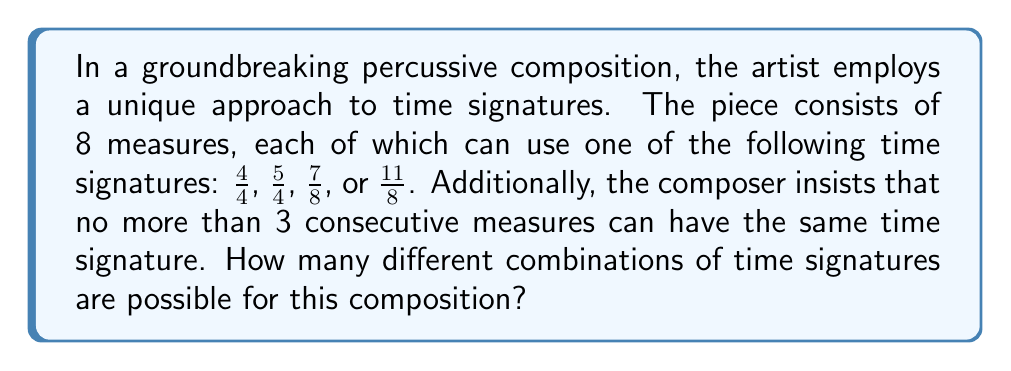Solve this math problem. Let's approach this step-by-step:

1) First, we need to consider the total number of possible combinations without the restriction:
   With 4 choices for each of the 8 measures, we would have $4^8 = 65,536$ combinations.

2) However, we need to subtract the combinations that violate the rule of no more than 3 consecutive measures with the same time signature.

3) To count these invalid combinations, we can use the Inclusion-Exclusion Principle:

   a) Count combinations with at least 4 consecutive same signatures starting at measure 1: $4 \cdot 4^4 = 1,024$
   b) Count those starting at measure 2: $4 \cdot 4 \cdot 4^3 = 1,024$
   c) Count those starting at measure 3: $4 \cdot 4 \cdot 4 \cdot 4^2 = 1,024$
   d) Count those starting at measure 4: $4 \cdot 4 \cdot 4 \cdot 4 \cdot 4 = 1,024$
   e) Count those starting at measure 5: $4^4 \cdot 4 = 1,024$

4) However, this double-counts some combinations. We need to subtract:
   Combinations with 5 consecutive same signatures: $4 \cdot 4^3 \cdot 5 = 1,280$

5) The total number of valid combinations is thus:
   $$65,536 - (5 \cdot 1,024 - 1,280) = 65,536 - 3,840 = 61,696$$

Therefore, there are 61,696 possible combinations of time signatures for this composition.
Answer: 61,696 